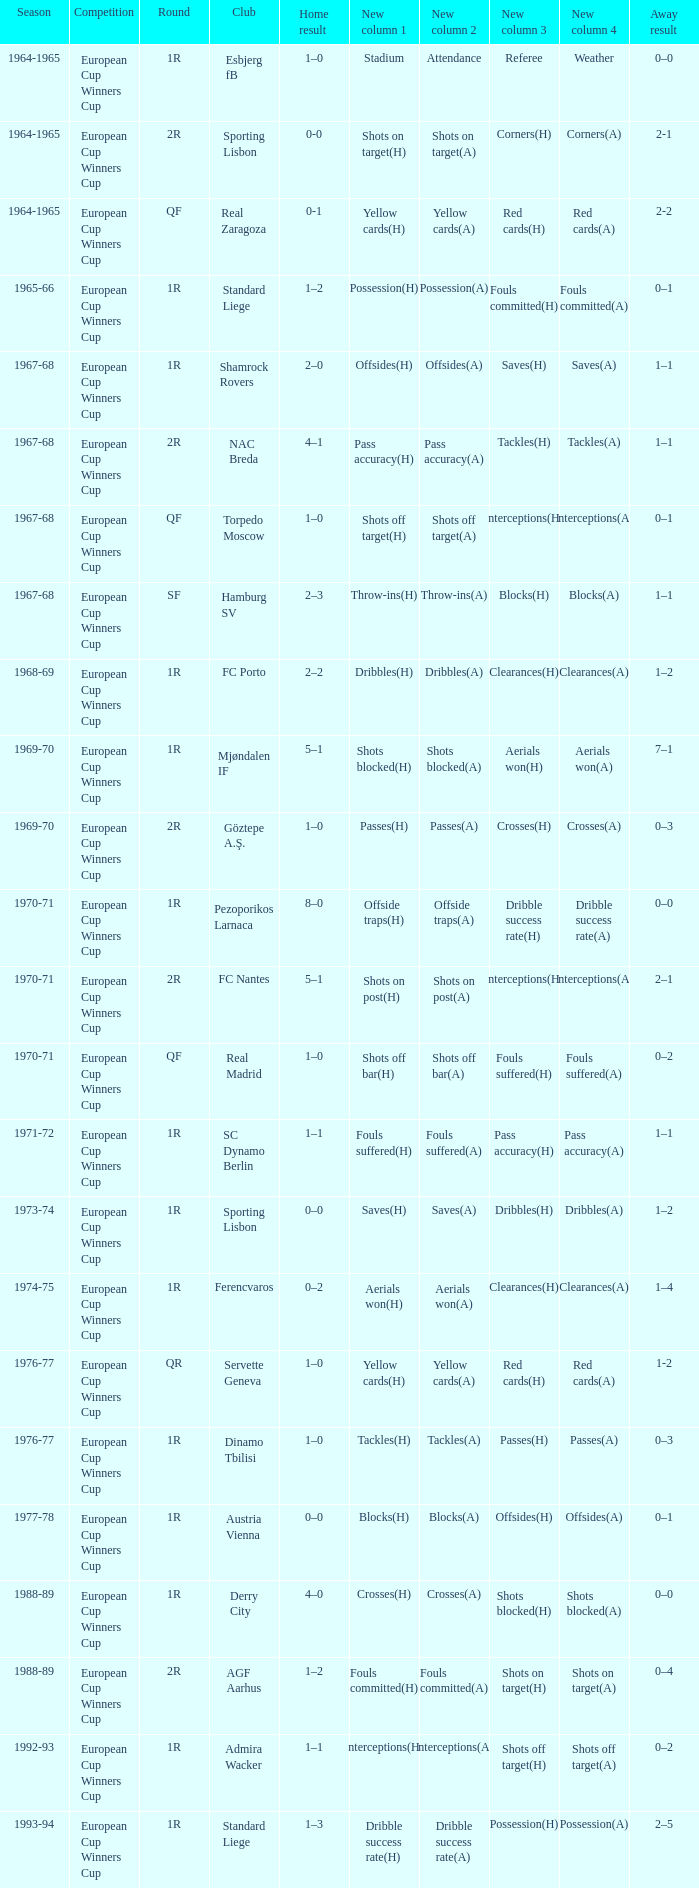Away result of 0–3, and a Season of 1969-70 is what competition? European Cup Winners Cup. Give me the full table as a dictionary. {'header': ['Season', 'Competition', 'Round', 'Club', 'Home result', 'New column 1', 'New column 2', 'New column 3', 'New column 4', 'Away result'], 'rows': [['1964-1965', 'European Cup Winners Cup', '1R', 'Esbjerg fB', '1–0', 'Stadium', 'Attendance', 'Referee', 'Weather', '0–0'], ['1964-1965', 'European Cup Winners Cup', '2R', 'Sporting Lisbon', '0-0', 'Shots on target(H)', 'Shots on target(A)', 'Corners(H)', 'Corners(A)', '2-1'], ['1964-1965', 'European Cup Winners Cup', 'QF', 'Real Zaragoza', '0-1', 'Yellow cards(H)', 'Yellow cards(A)', 'Red cards(H)', 'Red cards(A)', '2-2'], ['1965-66', 'European Cup Winners Cup', '1R', 'Standard Liege', '1–2', 'Possession(H)', 'Possession(A)', 'Fouls committed(H)', 'Fouls committed(A)', '0–1'], ['1967-68', 'European Cup Winners Cup', '1R', 'Shamrock Rovers', '2–0', 'Offsides(H)', 'Offsides(A)', 'Saves(H)', 'Saves(A)', '1–1'], ['1967-68', 'European Cup Winners Cup', '2R', 'NAC Breda', '4–1', 'Pass accuracy(H)', 'Pass accuracy(A)', 'Tackles(H)', 'Tackles(A)', '1–1'], ['1967-68', 'European Cup Winners Cup', 'QF', 'Torpedo Moscow', '1–0', 'Shots off target(H)', 'Shots off target(A)', 'Interceptions(H)', 'Interceptions(A)', '0–1'], ['1967-68', 'European Cup Winners Cup', 'SF', 'Hamburg SV', '2–3', 'Throw-ins(H)', 'Throw-ins(A)', 'Blocks(H)', 'Blocks(A)', '1–1'], ['1968-69', 'European Cup Winners Cup', '1R', 'FC Porto', '2–2', 'Dribbles(H)', 'Dribbles(A)', 'Clearances(H)', 'Clearances(A)', '1–2'], ['1969-70', 'European Cup Winners Cup', '1R', 'Mjøndalen IF', '5–1', 'Shots blocked(H)', 'Shots blocked(A)', 'Aerials won(H)', 'Aerials won(A)', '7–1'], ['1969-70', 'European Cup Winners Cup', '2R', 'Göztepe A.Ş.', '1–0', 'Passes(H)', 'Passes(A)', 'Crosses(H)', 'Crosses(A)', '0–3'], ['1970-71', 'European Cup Winners Cup', '1R', 'Pezoporikos Larnaca', '8–0', 'Offside traps(H)', 'Offside traps(A)', 'Dribble success rate(H)', 'Dribble success rate(A)', '0–0'], ['1970-71', 'European Cup Winners Cup', '2R', 'FC Nantes', '5–1', 'Shots on post(H)', 'Shots on post(A)', 'Interceptions(H)', 'Interceptions(A)', '2–1'], ['1970-71', 'European Cup Winners Cup', 'QF', 'Real Madrid', '1–0', 'Shots off bar(H)', 'Shots off bar(A)', 'Fouls suffered(H)', 'Fouls suffered(A)', '0–2'], ['1971-72', 'European Cup Winners Cup', '1R', 'SC Dynamo Berlin', '1–1', 'Fouls suffered(H)', 'Fouls suffered(A)', 'Pass accuracy(H)', 'Pass accuracy(A)', '1–1'], ['1973-74', 'European Cup Winners Cup', '1R', 'Sporting Lisbon', '0–0', 'Saves(H)', 'Saves(A)', 'Dribbles(H)', 'Dribbles(A)', '1–2'], ['1974-75', 'European Cup Winners Cup', '1R', 'Ferencvaros', '0–2', 'Aerials won(H)', 'Aerials won(A)', 'Clearances(H)', 'Clearances(A)', '1–4'], ['1976-77', 'European Cup Winners Cup', 'QR', 'Servette Geneva', '1–0', 'Yellow cards(H)', 'Yellow cards(A)', 'Red cards(H)', 'Red cards(A)', '1-2'], ['1976-77', 'European Cup Winners Cup', '1R', 'Dinamo Tbilisi', '1–0', 'Tackles(H)', 'Tackles(A)', 'Passes(H)', 'Passes(A)', '0–3'], ['1977-78', 'European Cup Winners Cup', '1R', 'Austria Vienna', '0–0', 'Blocks(H)', 'Blocks(A)', 'Offsides(H)', 'Offsides(A)', '0–1'], ['1988-89', 'European Cup Winners Cup', '1R', 'Derry City', '4–0', 'Crosses(H)', 'Crosses(A)', 'Shots blocked(H)', 'Shots blocked(A)', '0–0'], ['1988-89', 'European Cup Winners Cup', '2R', 'AGF Aarhus', '1–2', 'Fouls committed(H)', 'Fouls committed(A)', 'Shots on target(H)', 'Shots on target(A)', '0–4'], ['1992-93', 'European Cup Winners Cup', '1R', 'Admira Wacker', '1–1', 'Interceptions(H)', 'Interceptions(A)', 'Shots off target(H)', 'Shots off target(A)', '0–2'], ['1993-94', 'European Cup Winners Cup', '1R', 'Standard Liege', '1–3', 'Dribble success rate(H)', 'Dribble success rate(A)', 'Possession(H)', 'Possession(A)', '2–5']]} 